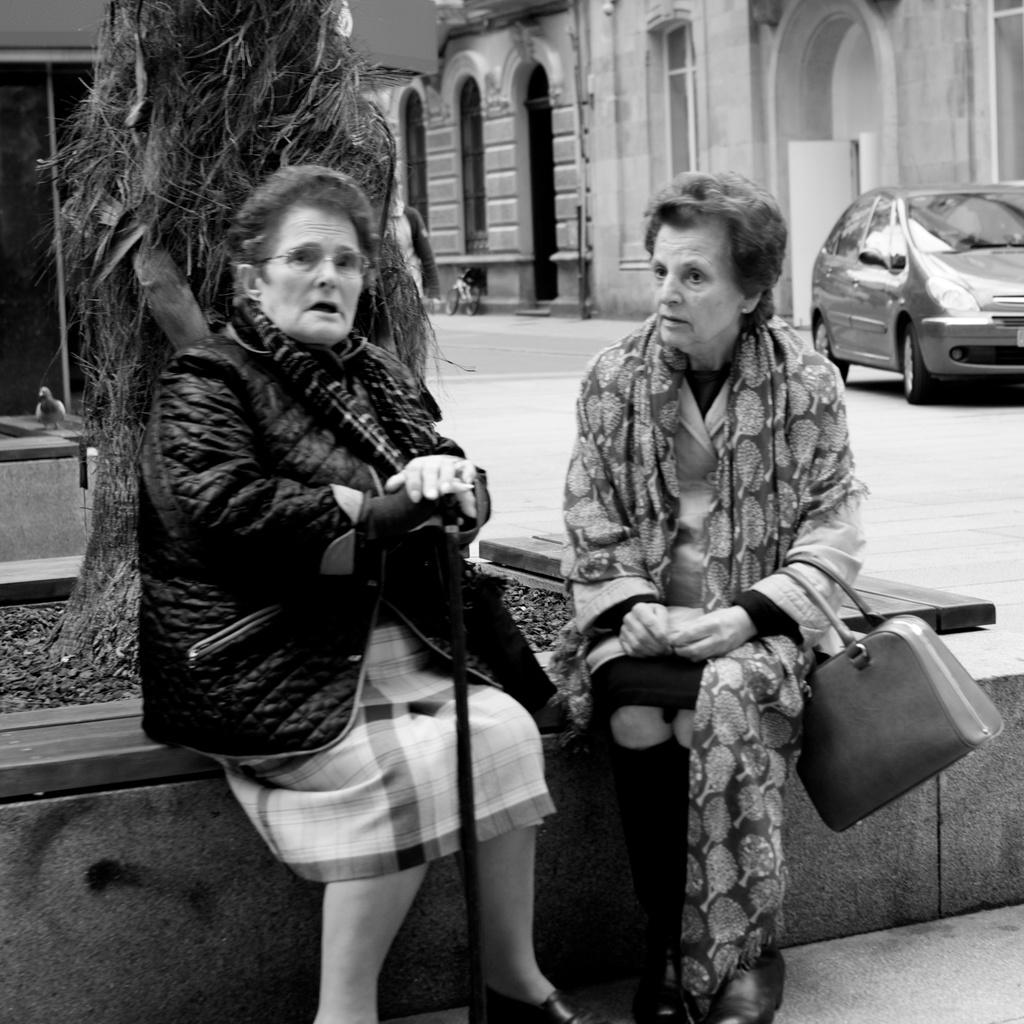Who can be seen in the front of the image? There are two people sitting in the front of the image. What is the tree stem in the image? There is a tree stem in the image. What type of structures are visible in the image? There are buildings visible in the image. What mode of transportation can be seen in the image? There is a car in the image. What type of amusement can be seen in the image? There is no amusement present in the image; it features two people sitting, a tree stem, buildings, and a car. Can you tell me which person is wearing a wristwatch in the image? There is no information about wristwatches or any specific accessories worn by the people in the image. 